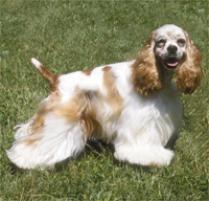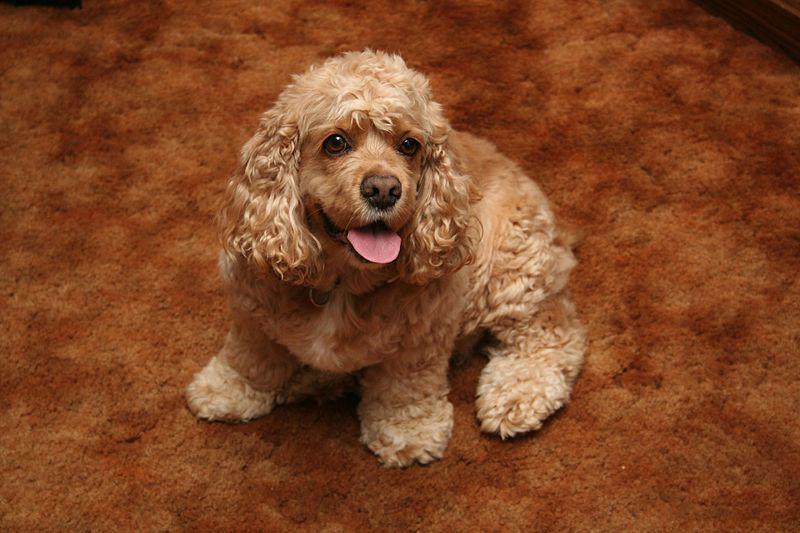The first image is the image on the left, the second image is the image on the right. For the images shown, is this caption "One image shows a golden-colored cocker spaniel standing on the grass, body turned to the left." true? Answer yes or no. No. The first image is the image on the left, the second image is the image on the right. For the images displayed, is the sentence "One dog is sitting down while the other dog is standing on all fours" factually correct? Answer yes or no. Yes. 